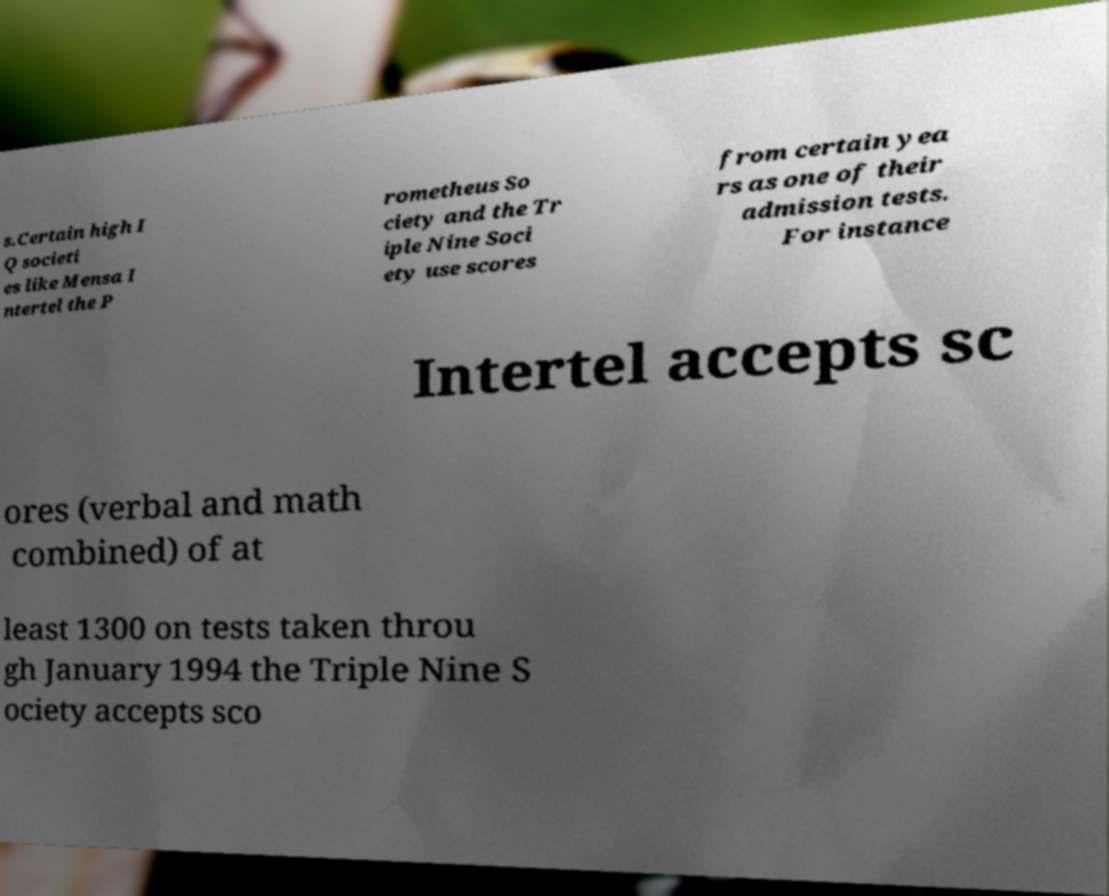Please read and relay the text visible in this image. What does it say? s.Certain high I Q societi es like Mensa I ntertel the P rometheus So ciety and the Tr iple Nine Soci ety use scores from certain yea rs as one of their admission tests. For instance Intertel accepts sc ores (verbal and math combined) of at least 1300 on tests taken throu gh January 1994 the Triple Nine S ociety accepts sco 